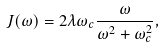<formula> <loc_0><loc_0><loc_500><loc_500>J ( \omega ) = 2 \lambda \omega _ { c } \frac { \omega } { \omega ^ { 2 } + \omega _ { c } ^ { 2 } } ,</formula> 